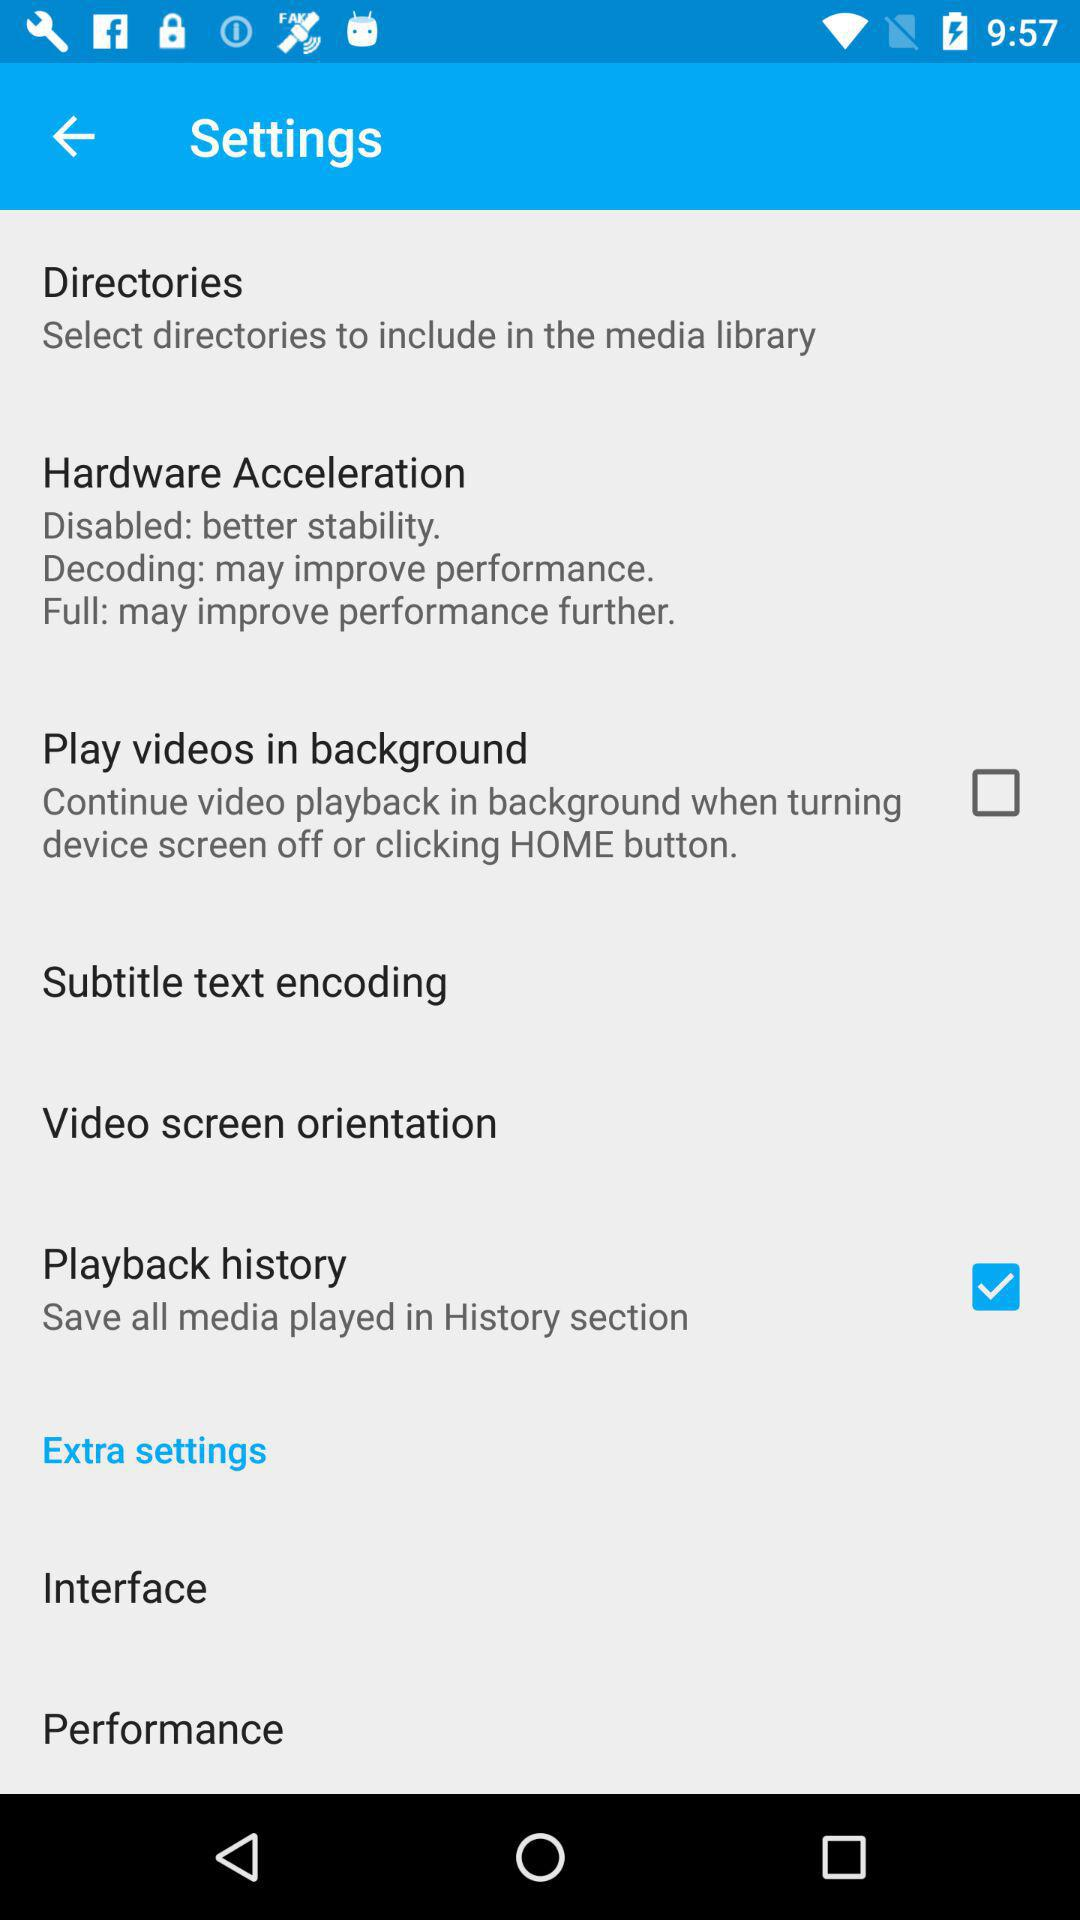How many Hz bands are there in the equalizer?
Answer the question using a single word or phrase. 6 